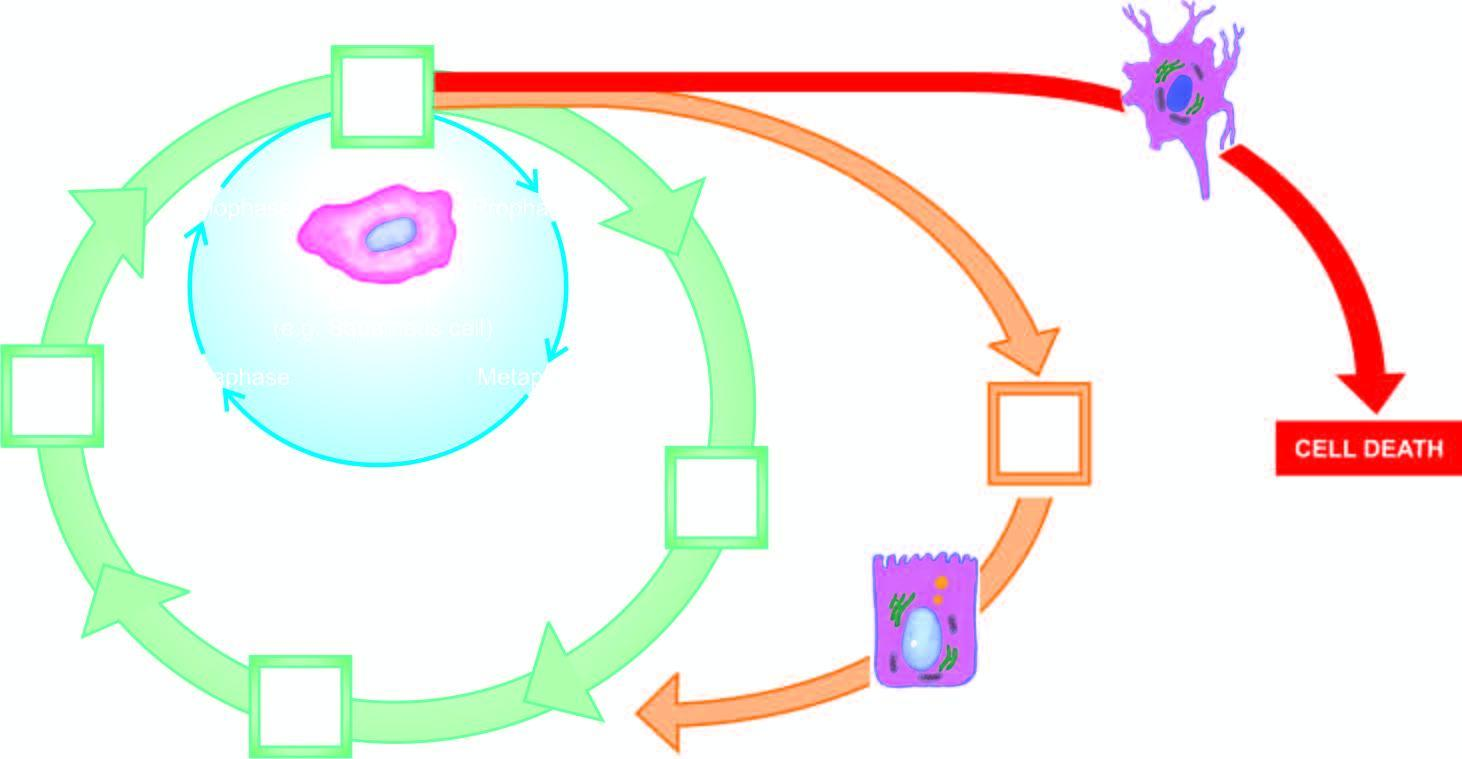what is the circle shown with?
Answer the question using a single word or phrase. Red line represents cell cycle for permanent cells 